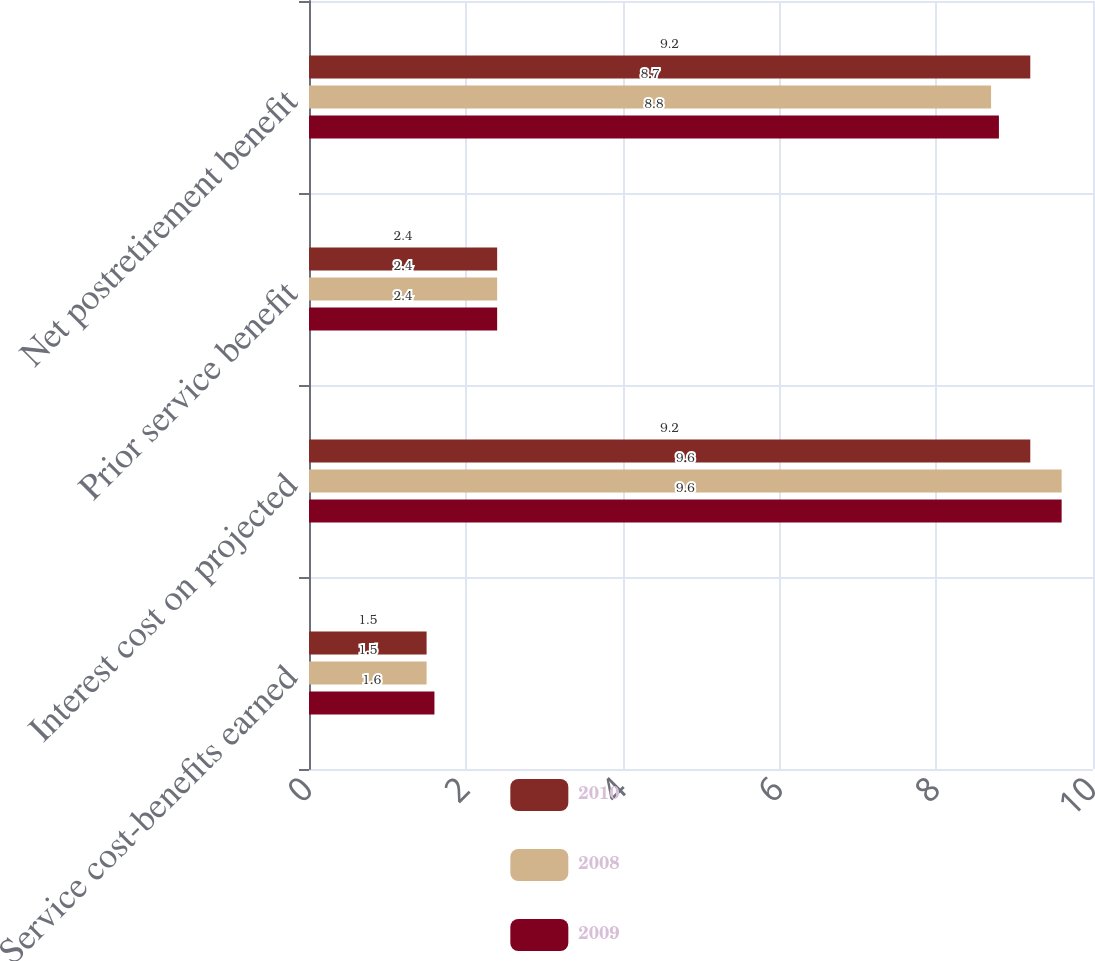<chart> <loc_0><loc_0><loc_500><loc_500><stacked_bar_chart><ecel><fcel>Service cost-benefits earned<fcel>Interest cost on projected<fcel>Prior service benefit<fcel>Net postretirement benefit<nl><fcel>2010<fcel>1.5<fcel>9.2<fcel>2.4<fcel>9.2<nl><fcel>2008<fcel>1.5<fcel>9.6<fcel>2.4<fcel>8.7<nl><fcel>2009<fcel>1.6<fcel>9.6<fcel>2.4<fcel>8.8<nl></chart> 